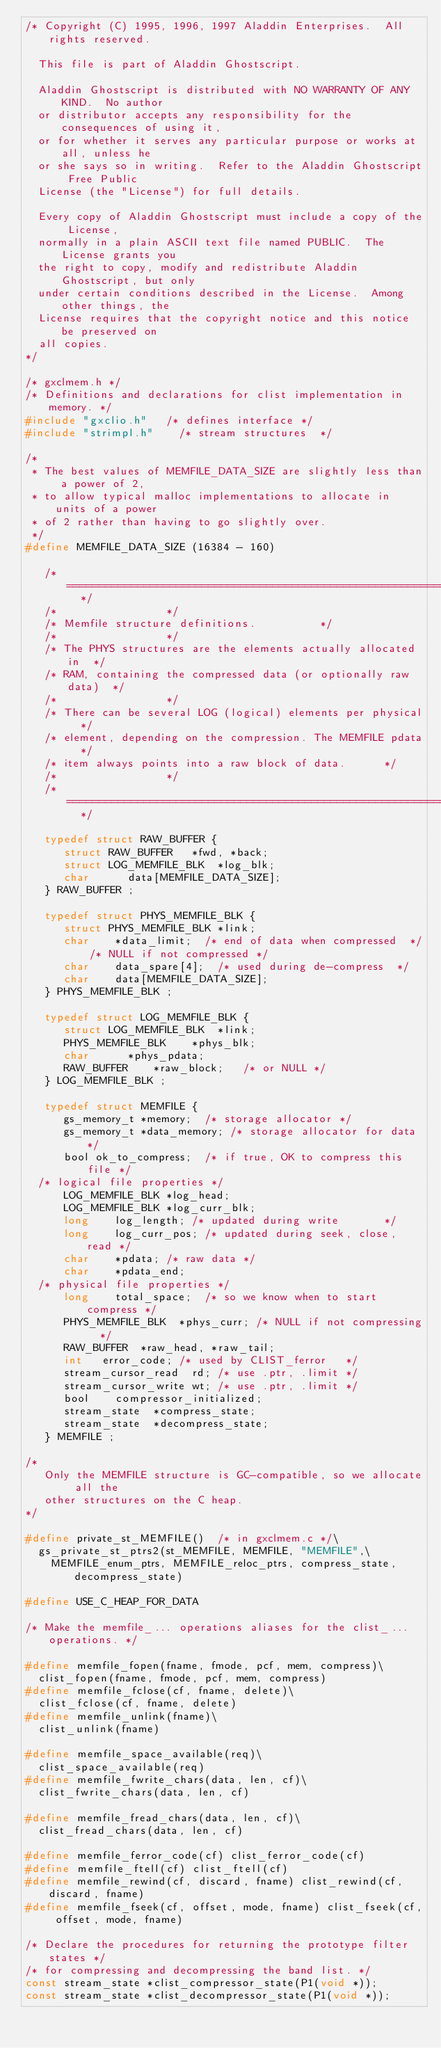<code> <loc_0><loc_0><loc_500><loc_500><_C_>/* Copyright (C) 1995, 1996, 1997 Aladdin Enterprises.  All rights reserved.
  
  This file is part of Aladdin Ghostscript.
  
  Aladdin Ghostscript is distributed with NO WARRANTY OF ANY KIND.  No author
  or distributor accepts any responsibility for the consequences of using it,
  or for whether it serves any particular purpose or works at all, unless he
  or she says so in writing.  Refer to the Aladdin Ghostscript Free Public
  License (the "License") for full details.
  
  Every copy of Aladdin Ghostscript must include a copy of the License,
  normally in a plain ASCII text file named PUBLIC.  The License grants you
  the right to copy, modify and redistribute Aladdin Ghostscript, but only
  under certain conditions described in the License.  Among other things, the
  License requires that the copyright notice and this notice be preserved on
  all copies.
*/

/* gxclmem.h */
/* Definitions and declarations for clist implementation in memory. */
#include "gxclio.h"		/* defines interface */
#include "strimpl.h"		/* stream structures	*/

/*
 * The best values of MEMFILE_DATA_SIZE are slightly less than a power of 2,
 * to allow typical malloc implementations to allocate in units of a power
 * of 2 rather than having to go slightly over.
 */
#define MEMFILE_DATA_SIZE	(16384 - 160)

   /*	============================================================	*/
   /*									*/
   /*	Memfile structure definitions.					*/
   /*									*/
   /*	The PHYS structures are the elements actually allocated in	*/
   /*	RAM, containing the compressed data (or optionally raw data)	*/
   /*									*/
   /*	There can be several LOG (logical) elements per physical	*/
   /*	element, depending on the compression. The MEMFILE pdata	*/
   /*	item always points into a raw block of data.			*/
   /*									*/
   /*	============================================================	*/

   typedef struct RAW_BUFFER {
      struct RAW_BUFFER		*fwd, *back;
      struct LOG_MEMFILE_BLK	*log_blk;
      char			data[MEMFILE_DATA_SIZE];
   } RAW_BUFFER ;

   typedef struct PHYS_MEMFILE_BLK {
      struct PHYS_MEMFILE_BLK	*link;
      char		*data_limit;	/* end of data when compressed	*/
					/* NULL if not compressed	*/
      char		data_spare[4];	/* used during de-compress	*/
      char		data[MEMFILE_DATA_SIZE];
   } PHYS_MEMFILE_BLK ;

   typedef struct LOG_MEMFILE_BLK {
      struct LOG_MEMFILE_BLK	*link;
      PHYS_MEMFILE_BLK		*phys_blk;
      char			*phys_pdata;
      RAW_BUFFER		*raw_block;		/* or NULL */
   } LOG_MEMFILE_BLK ;

   typedef struct MEMFILE {
      gs_memory_t *memory;	/* storage allocator */
      gs_memory_t *data_memory;	/* storage allocator for data */
      bool ok_to_compress;	/* if true, OK to compress this file */
	/* logical file properties */
      LOG_MEMFILE_BLK	*log_head;
      LOG_MEMFILE_BLK	*log_curr_blk;
      long		log_length;	/* updated during write		    */
      long		log_curr_pos;	/* updated during seek, close, read */
      char		*pdata;	/* raw data */
      char		*pdata_end;
	/* physical file properties */
      long		total_space;	/* so we know when to start compress */
      PHYS_MEMFILE_BLK	*phys_curr;	/* NULL if not compressing	*/
      RAW_BUFFER	*raw_head, *raw_tail;
      int		error_code;	/* used by CLIST_ferror		*/
      stream_cursor_read  rd;	/* use .ptr, .limit */
      stream_cursor_write wt;	/* use .ptr, .limit */
      bool		compressor_initialized;
      stream_state	*compress_state;
      stream_state	*decompress_state;
   } MEMFILE ;

/*
   Only the MEMFILE structure is GC-compatible, so we allocate all the
   other structures on the C heap.
*/

#define private_st_MEMFILE()	/* in gxclmem.c */\
  gs_private_st_ptrs2(st_MEMFILE, MEMFILE, "MEMFILE",\
    MEMFILE_enum_ptrs, MEMFILE_reloc_ptrs, compress_state, decompress_state)

#define USE_C_HEAP_FOR_DATA

/* Make the memfile_... operations aliases for the clist_... operations. */

#define memfile_fopen(fname, fmode, pcf, mem, compress)\
  clist_fopen(fname, fmode, pcf, mem, compress)
#define memfile_fclose(cf, fname, delete)\
  clist_fclose(cf, fname, delete)
#define memfile_unlink(fname)\
  clist_unlink(fname)

#define memfile_space_available(req)\
  clist_space_available(req)
#define memfile_fwrite_chars(data, len, cf)\
  clist_fwrite_chars(data, len, cf)

#define memfile_fread_chars(data, len, cf)\
  clist_fread_chars(data, len, cf)

#define memfile_ferror_code(cf) clist_ferror_code(cf)
#define memfile_ftell(cf) clist_ftell(cf)
#define memfile_rewind(cf, discard, fname) clist_rewind(cf, discard, fname)
#define memfile_fseek(cf, offset, mode, fname) clist_fseek(cf, offset, mode, fname)

/* Declare the procedures for returning the prototype filter states */
/* for compressing and decompressing the band list. */
const stream_state *clist_compressor_state(P1(void *));
const stream_state *clist_decompressor_state(P1(void *));
</code> 